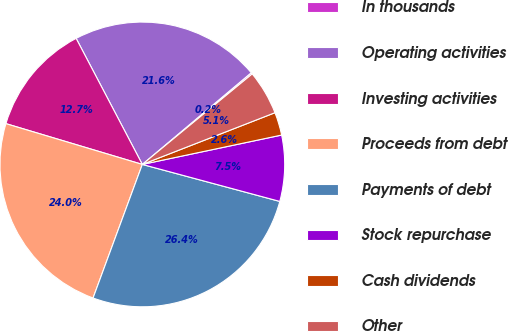<chart> <loc_0><loc_0><loc_500><loc_500><pie_chart><fcel>In thousands<fcel>Operating activities<fcel>Investing activities<fcel>Proceeds from debt<fcel>Payments of debt<fcel>Stock repurchase<fcel>Cash dividends<fcel>Other<nl><fcel>0.17%<fcel>21.56%<fcel>12.68%<fcel>24.0%<fcel>26.44%<fcel>7.49%<fcel>2.61%<fcel>5.05%<nl></chart> 